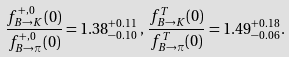<formula> <loc_0><loc_0><loc_500><loc_500>\frac { f ^ { + , 0 } _ { B \to K } ( 0 ) } { f ^ { + , 0 } _ { B \to \pi } ( 0 ) } = 1 . 3 8 ^ { + 0 . 1 1 } _ { - 0 . 1 0 } \, , \, \frac { f ^ { T } _ { B \to K } ( 0 ) } { f ^ { T } _ { B \to \pi } ( 0 ) } = 1 . 4 9 ^ { + 0 . 1 8 } _ { - 0 . 0 6 } .</formula> 